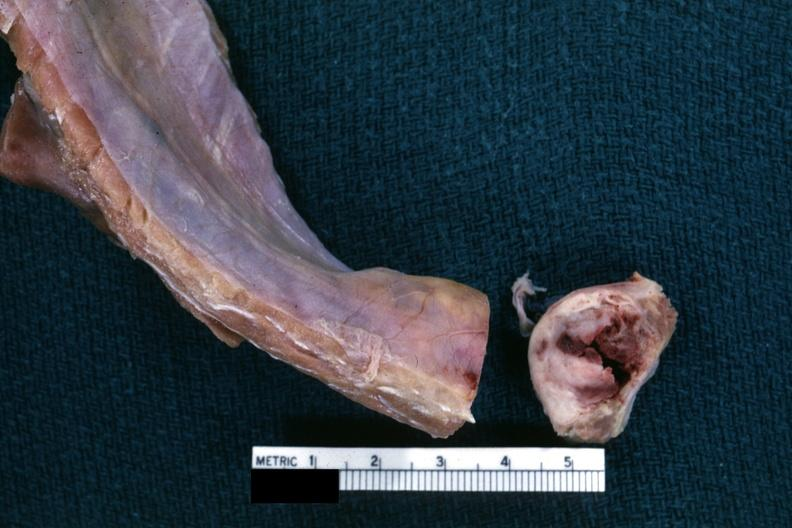s joints present?
Answer the question using a single word or phrase. Yes 